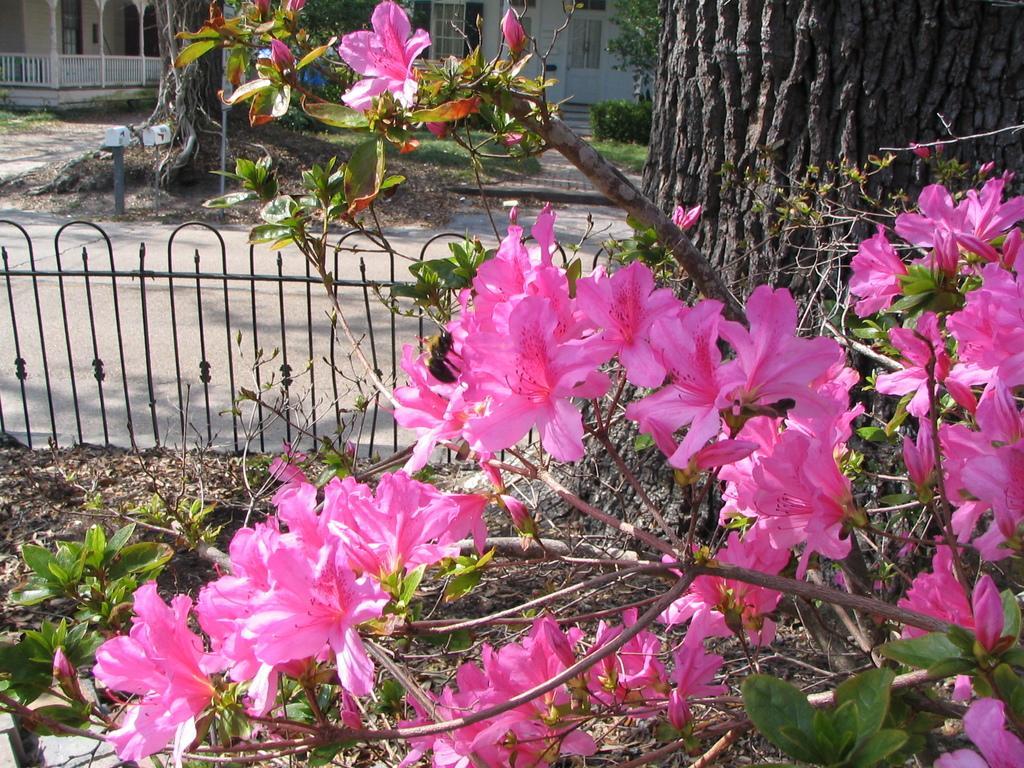Please provide a concise description of this image. At the bottom of the image there are some flowers and trees. Behind the trees there is fencing. At the top of the image there are some trees, plants and building. 